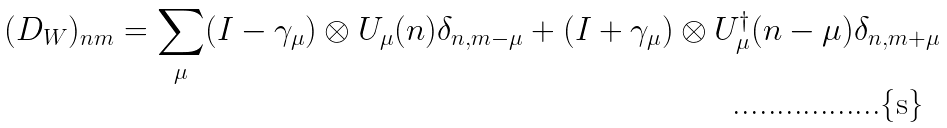Convert formula to latex. <formula><loc_0><loc_0><loc_500><loc_500>( D _ { W } ) _ { n m } = \sum _ { \mu } ( I - \gamma _ { \mu } ) \otimes U _ { \mu } ( n ) \delta _ { n , m - \mu } + ( I + \gamma _ { \mu } ) \otimes U ^ { \dagger } _ { \mu } ( n - \mu ) \delta _ { n , m + \mu }</formula> 